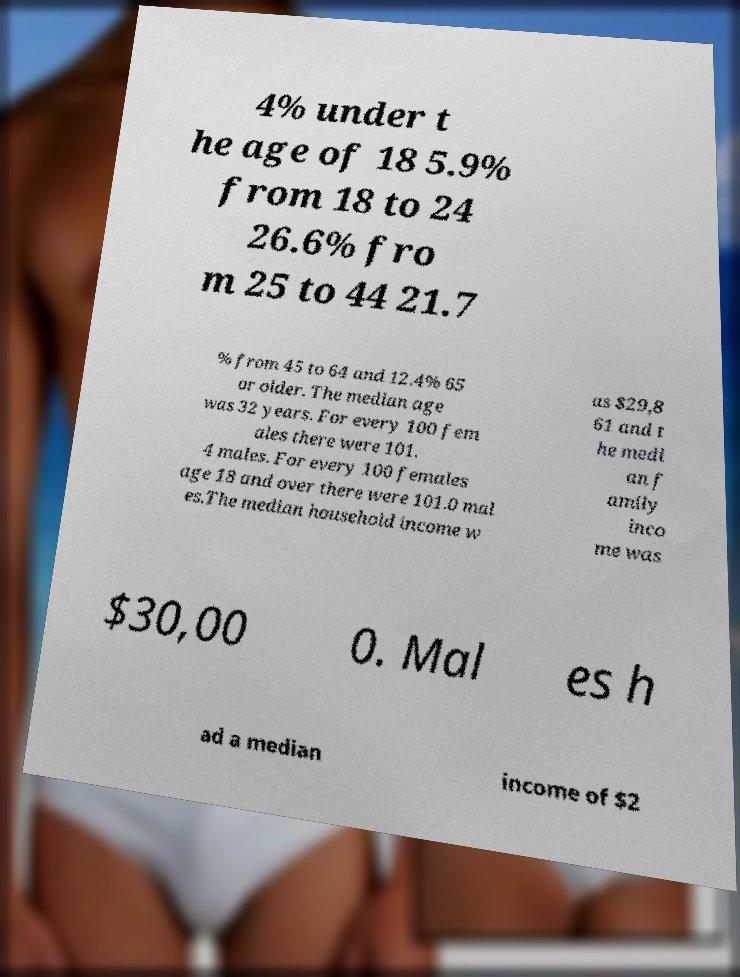Could you assist in decoding the text presented in this image and type it out clearly? 4% under t he age of 18 5.9% from 18 to 24 26.6% fro m 25 to 44 21.7 % from 45 to 64 and 12.4% 65 or older. The median age was 32 years. For every 100 fem ales there were 101. 4 males. For every 100 females age 18 and over there were 101.0 mal es.The median household income w as $29,8 61 and t he medi an f amily inco me was $30,00 0. Mal es h ad a median income of $2 